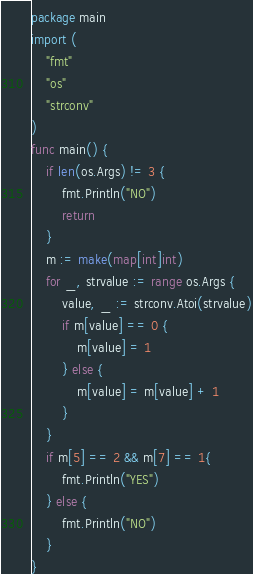Convert code to text. <code><loc_0><loc_0><loc_500><loc_500><_Go_>package main
import (
	"fmt"
	"os"
	"strconv"
)
func main() {
	if len(os.Args) != 3 {
		fmt.Println("NO")
		return
	}
	m := make(map[int]int)
	for _, strvalue := range os.Args {
		value, _ := strconv.Atoi(strvalue)
		if m[value] == 0 {
			m[value] = 1
		} else {
			m[value] = m[value] + 1
		}
	}
	if m[5] == 2 && m[7] == 1{
		fmt.Println("YES")
	} else {
		fmt.Println("NO")
	}
}
</code> 